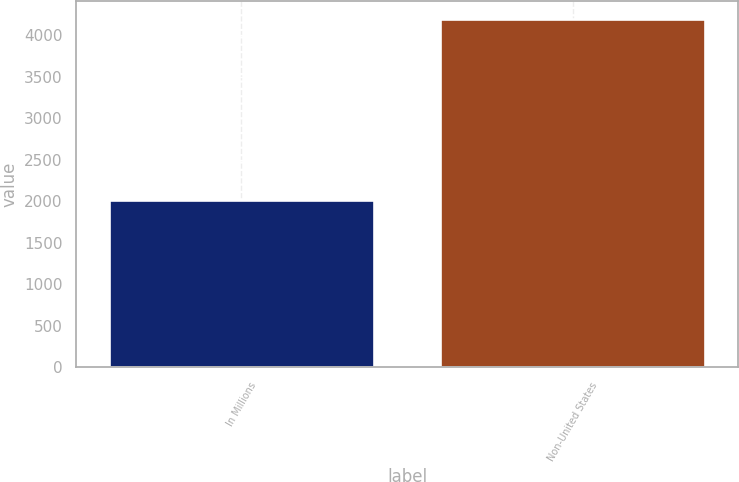<chart> <loc_0><loc_0><loc_500><loc_500><bar_chart><fcel>In Millions<fcel>Non-United States<nl><fcel>2012<fcel>4195.8<nl></chart> 